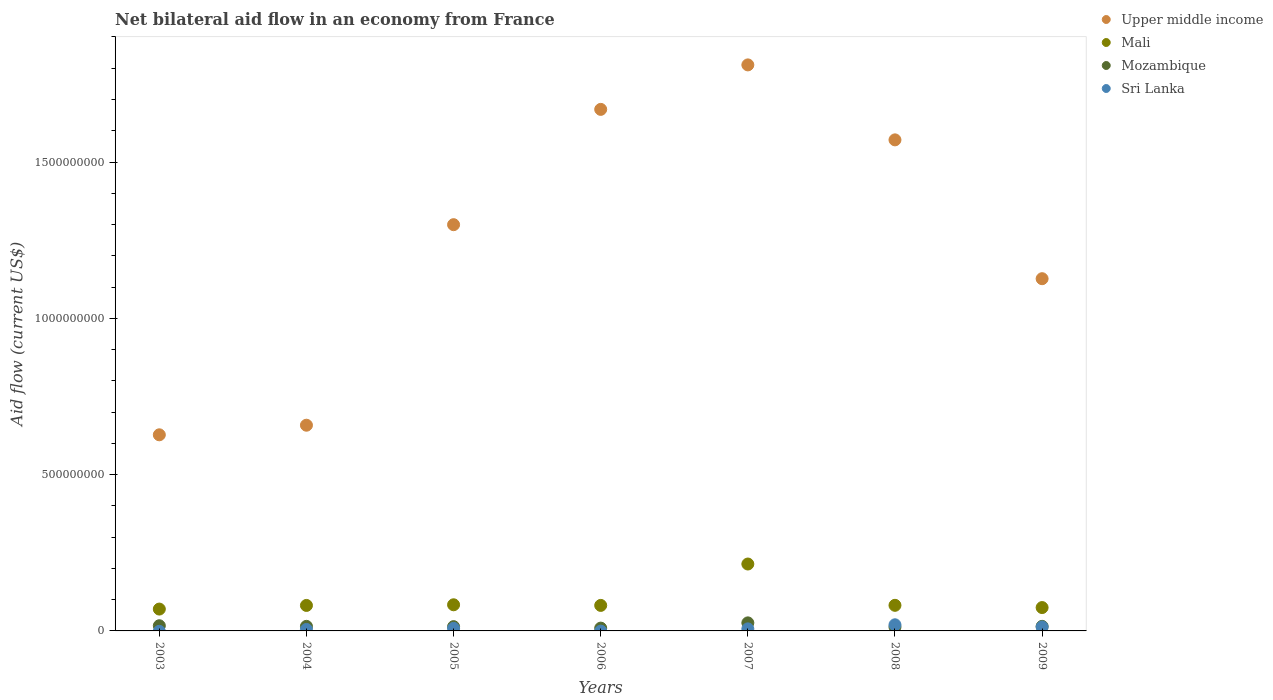Is the number of dotlines equal to the number of legend labels?
Your answer should be very brief. No. What is the net bilateral aid flow in Mozambique in 2004?
Keep it short and to the point. 1.46e+07. Across all years, what is the maximum net bilateral aid flow in Mali?
Make the answer very short. 2.14e+08. Across all years, what is the minimum net bilateral aid flow in Mozambique?
Make the answer very short. 8.98e+06. In which year was the net bilateral aid flow in Mozambique maximum?
Give a very brief answer. 2007. What is the total net bilateral aid flow in Mali in the graph?
Ensure brevity in your answer.  6.87e+08. What is the difference between the net bilateral aid flow in Upper middle income in 2007 and that in 2009?
Offer a terse response. 6.84e+08. What is the difference between the net bilateral aid flow in Mali in 2003 and the net bilateral aid flow in Upper middle income in 2009?
Offer a very short reply. -1.06e+09. What is the average net bilateral aid flow in Mali per year?
Keep it short and to the point. 9.82e+07. In the year 2005, what is the difference between the net bilateral aid flow in Mali and net bilateral aid flow in Sri Lanka?
Provide a short and direct response. 7.54e+07. In how many years, is the net bilateral aid flow in Mozambique greater than 1100000000 US$?
Your answer should be very brief. 0. What is the ratio of the net bilateral aid flow in Mozambique in 2004 to that in 2008?
Offer a very short reply. 1.19. What is the difference between the highest and the second highest net bilateral aid flow in Sri Lanka?
Make the answer very short. 6.92e+06. What is the difference between the highest and the lowest net bilateral aid flow in Sri Lanka?
Your answer should be very brief. 1.96e+07. In how many years, is the net bilateral aid flow in Upper middle income greater than the average net bilateral aid flow in Upper middle income taken over all years?
Make the answer very short. 4. Is the sum of the net bilateral aid flow in Mozambique in 2004 and 2007 greater than the maximum net bilateral aid flow in Upper middle income across all years?
Your answer should be very brief. No. Does the net bilateral aid flow in Mali monotonically increase over the years?
Offer a very short reply. No. Is the net bilateral aid flow in Sri Lanka strictly greater than the net bilateral aid flow in Mozambique over the years?
Ensure brevity in your answer.  No. Is the net bilateral aid flow in Upper middle income strictly less than the net bilateral aid flow in Mozambique over the years?
Your response must be concise. No. Does the graph contain any zero values?
Give a very brief answer. Yes. Where does the legend appear in the graph?
Give a very brief answer. Top right. How many legend labels are there?
Your answer should be very brief. 4. What is the title of the graph?
Provide a short and direct response. Net bilateral aid flow in an economy from France. What is the label or title of the X-axis?
Ensure brevity in your answer.  Years. What is the label or title of the Y-axis?
Provide a succinct answer. Aid flow (current US$). What is the Aid flow (current US$) of Upper middle income in 2003?
Offer a very short reply. 6.27e+08. What is the Aid flow (current US$) of Mali in 2003?
Your response must be concise. 6.99e+07. What is the Aid flow (current US$) of Mozambique in 2003?
Your answer should be compact. 1.66e+07. What is the Aid flow (current US$) of Upper middle income in 2004?
Provide a short and direct response. 6.58e+08. What is the Aid flow (current US$) of Mali in 2004?
Ensure brevity in your answer.  8.15e+07. What is the Aid flow (current US$) in Mozambique in 2004?
Offer a terse response. 1.46e+07. What is the Aid flow (current US$) of Sri Lanka in 2004?
Your response must be concise. 4.66e+06. What is the Aid flow (current US$) in Upper middle income in 2005?
Your answer should be very brief. 1.30e+09. What is the Aid flow (current US$) of Mali in 2005?
Give a very brief answer. 8.36e+07. What is the Aid flow (current US$) in Mozambique in 2005?
Provide a short and direct response. 1.37e+07. What is the Aid flow (current US$) of Sri Lanka in 2005?
Make the answer very short. 8.26e+06. What is the Aid flow (current US$) in Upper middle income in 2006?
Provide a short and direct response. 1.67e+09. What is the Aid flow (current US$) in Mali in 2006?
Offer a very short reply. 8.16e+07. What is the Aid flow (current US$) of Mozambique in 2006?
Your response must be concise. 8.98e+06. What is the Aid flow (current US$) of Sri Lanka in 2006?
Offer a very short reply. 0. What is the Aid flow (current US$) of Upper middle income in 2007?
Ensure brevity in your answer.  1.81e+09. What is the Aid flow (current US$) of Mali in 2007?
Offer a very short reply. 2.14e+08. What is the Aid flow (current US$) in Mozambique in 2007?
Provide a succinct answer. 2.57e+07. What is the Aid flow (current US$) of Sri Lanka in 2007?
Offer a very short reply. 6.54e+06. What is the Aid flow (current US$) in Upper middle income in 2008?
Your answer should be compact. 1.57e+09. What is the Aid flow (current US$) of Mali in 2008?
Ensure brevity in your answer.  8.19e+07. What is the Aid flow (current US$) in Mozambique in 2008?
Offer a terse response. 1.23e+07. What is the Aid flow (current US$) in Sri Lanka in 2008?
Offer a terse response. 1.96e+07. What is the Aid flow (current US$) of Upper middle income in 2009?
Your answer should be very brief. 1.13e+09. What is the Aid flow (current US$) in Mali in 2009?
Give a very brief answer. 7.47e+07. What is the Aid flow (current US$) of Mozambique in 2009?
Your response must be concise. 1.46e+07. What is the Aid flow (current US$) of Sri Lanka in 2009?
Provide a short and direct response. 1.27e+07. Across all years, what is the maximum Aid flow (current US$) in Upper middle income?
Provide a short and direct response. 1.81e+09. Across all years, what is the maximum Aid flow (current US$) of Mali?
Provide a succinct answer. 2.14e+08. Across all years, what is the maximum Aid flow (current US$) of Mozambique?
Give a very brief answer. 2.57e+07. Across all years, what is the maximum Aid flow (current US$) of Sri Lanka?
Your response must be concise. 1.96e+07. Across all years, what is the minimum Aid flow (current US$) of Upper middle income?
Offer a very short reply. 6.27e+08. Across all years, what is the minimum Aid flow (current US$) of Mali?
Ensure brevity in your answer.  6.99e+07. Across all years, what is the minimum Aid flow (current US$) in Mozambique?
Your answer should be compact. 8.98e+06. What is the total Aid flow (current US$) of Upper middle income in the graph?
Offer a very short reply. 8.76e+09. What is the total Aid flow (current US$) of Mali in the graph?
Your answer should be compact. 6.87e+08. What is the total Aid flow (current US$) of Mozambique in the graph?
Offer a terse response. 1.07e+08. What is the total Aid flow (current US$) in Sri Lanka in the graph?
Offer a terse response. 5.18e+07. What is the difference between the Aid flow (current US$) in Upper middle income in 2003 and that in 2004?
Make the answer very short. -3.07e+07. What is the difference between the Aid flow (current US$) of Mali in 2003 and that in 2004?
Ensure brevity in your answer.  -1.16e+07. What is the difference between the Aid flow (current US$) in Mozambique in 2003 and that in 2004?
Provide a succinct answer. 1.98e+06. What is the difference between the Aid flow (current US$) of Upper middle income in 2003 and that in 2005?
Your answer should be very brief. -6.72e+08. What is the difference between the Aid flow (current US$) of Mali in 2003 and that in 2005?
Your response must be concise. -1.37e+07. What is the difference between the Aid flow (current US$) in Mozambique in 2003 and that in 2005?
Provide a short and direct response. 2.91e+06. What is the difference between the Aid flow (current US$) of Upper middle income in 2003 and that in 2006?
Your answer should be very brief. -1.04e+09. What is the difference between the Aid flow (current US$) in Mali in 2003 and that in 2006?
Your response must be concise. -1.17e+07. What is the difference between the Aid flow (current US$) in Mozambique in 2003 and that in 2006?
Provide a succinct answer. 7.61e+06. What is the difference between the Aid flow (current US$) of Upper middle income in 2003 and that in 2007?
Provide a succinct answer. -1.18e+09. What is the difference between the Aid flow (current US$) in Mali in 2003 and that in 2007?
Your response must be concise. -1.44e+08. What is the difference between the Aid flow (current US$) of Mozambique in 2003 and that in 2007?
Offer a terse response. -9.15e+06. What is the difference between the Aid flow (current US$) in Upper middle income in 2003 and that in 2008?
Keep it short and to the point. -9.43e+08. What is the difference between the Aid flow (current US$) in Mali in 2003 and that in 2008?
Give a very brief answer. -1.20e+07. What is the difference between the Aid flow (current US$) in Mozambique in 2003 and that in 2008?
Offer a terse response. 4.28e+06. What is the difference between the Aid flow (current US$) of Upper middle income in 2003 and that in 2009?
Your answer should be very brief. -4.99e+08. What is the difference between the Aid flow (current US$) of Mali in 2003 and that in 2009?
Your response must be concise. -4.83e+06. What is the difference between the Aid flow (current US$) of Mozambique in 2003 and that in 2009?
Give a very brief answer. 1.94e+06. What is the difference between the Aid flow (current US$) in Upper middle income in 2004 and that in 2005?
Give a very brief answer. -6.41e+08. What is the difference between the Aid flow (current US$) of Mali in 2004 and that in 2005?
Make the answer very short. -2.09e+06. What is the difference between the Aid flow (current US$) in Mozambique in 2004 and that in 2005?
Give a very brief answer. 9.30e+05. What is the difference between the Aid flow (current US$) of Sri Lanka in 2004 and that in 2005?
Ensure brevity in your answer.  -3.60e+06. What is the difference between the Aid flow (current US$) of Upper middle income in 2004 and that in 2006?
Offer a very short reply. -1.01e+09. What is the difference between the Aid flow (current US$) in Mozambique in 2004 and that in 2006?
Ensure brevity in your answer.  5.63e+06. What is the difference between the Aid flow (current US$) of Upper middle income in 2004 and that in 2007?
Ensure brevity in your answer.  -1.15e+09. What is the difference between the Aid flow (current US$) in Mali in 2004 and that in 2007?
Offer a very short reply. -1.32e+08. What is the difference between the Aid flow (current US$) of Mozambique in 2004 and that in 2007?
Ensure brevity in your answer.  -1.11e+07. What is the difference between the Aid flow (current US$) of Sri Lanka in 2004 and that in 2007?
Offer a terse response. -1.88e+06. What is the difference between the Aid flow (current US$) of Upper middle income in 2004 and that in 2008?
Ensure brevity in your answer.  -9.13e+08. What is the difference between the Aid flow (current US$) of Mali in 2004 and that in 2008?
Provide a succinct answer. -3.80e+05. What is the difference between the Aid flow (current US$) of Mozambique in 2004 and that in 2008?
Your answer should be compact. 2.30e+06. What is the difference between the Aid flow (current US$) in Sri Lanka in 2004 and that in 2008?
Give a very brief answer. -1.50e+07. What is the difference between the Aid flow (current US$) in Upper middle income in 2004 and that in 2009?
Offer a terse response. -4.69e+08. What is the difference between the Aid flow (current US$) in Mali in 2004 and that in 2009?
Offer a very short reply. 6.80e+06. What is the difference between the Aid flow (current US$) of Mozambique in 2004 and that in 2009?
Provide a succinct answer. -4.00e+04. What is the difference between the Aid flow (current US$) of Sri Lanka in 2004 and that in 2009?
Provide a short and direct response. -8.03e+06. What is the difference between the Aid flow (current US$) of Upper middle income in 2005 and that in 2006?
Make the answer very short. -3.69e+08. What is the difference between the Aid flow (current US$) of Mali in 2005 and that in 2006?
Ensure brevity in your answer.  1.99e+06. What is the difference between the Aid flow (current US$) of Mozambique in 2005 and that in 2006?
Your answer should be compact. 4.70e+06. What is the difference between the Aid flow (current US$) in Upper middle income in 2005 and that in 2007?
Provide a succinct answer. -5.11e+08. What is the difference between the Aid flow (current US$) in Mali in 2005 and that in 2007?
Give a very brief answer. -1.30e+08. What is the difference between the Aid flow (current US$) in Mozambique in 2005 and that in 2007?
Provide a succinct answer. -1.21e+07. What is the difference between the Aid flow (current US$) of Sri Lanka in 2005 and that in 2007?
Offer a terse response. 1.72e+06. What is the difference between the Aid flow (current US$) in Upper middle income in 2005 and that in 2008?
Keep it short and to the point. -2.71e+08. What is the difference between the Aid flow (current US$) in Mali in 2005 and that in 2008?
Offer a very short reply. 1.71e+06. What is the difference between the Aid flow (current US$) of Mozambique in 2005 and that in 2008?
Your response must be concise. 1.37e+06. What is the difference between the Aid flow (current US$) of Sri Lanka in 2005 and that in 2008?
Your answer should be compact. -1.14e+07. What is the difference between the Aid flow (current US$) in Upper middle income in 2005 and that in 2009?
Your answer should be very brief. 1.73e+08. What is the difference between the Aid flow (current US$) in Mali in 2005 and that in 2009?
Give a very brief answer. 8.89e+06. What is the difference between the Aid flow (current US$) in Mozambique in 2005 and that in 2009?
Keep it short and to the point. -9.70e+05. What is the difference between the Aid flow (current US$) in Sri Lanka in 2005 and that in 2009?
Keep it short and to the point. -4.43e+06. What is the difference between the Aid flow (current US$) in Upper middle income in 2006 and that in 2007?
Your answer should be very brief. -1.42e+08. What is the difference between the Aid flow (current US$) of Mali in 2006 and that in 2007?
Your answer should be very brief. -1.32e+08. What is the difference between the Aid flow (current US$) in Mozambique in 2006 and that in 2007?
Your answer should be compact. -1.68e+07. What is the difference between the Aid flow (current US$) in Upper middle income in 2006 and that in 2008?
Your answer should be compact. 9.75e+07. What is the difference between the Aid flow (current US$) in Mali in 2006 and that in 2008?
Your answer should be compact. -2.80e+05. What is the difference between the Aid flow (current US$) in Mozambique in 2006 and that in 2008?
Offer a terse response. -3.33e+06. What is the difference between the Aid flow (current US$) in Upper middle income in 2006 and that in 2009?
Provide a short and direct response. 5.42e+08. What is the difference between the Aid flow (current US$) in Mali in 2006 and that in 2009?
Provide a short and direct response. 6.90e+06. What is the difference between the Aid flow (current US$) in Mozambique in 2006 and that in 2009?
Provide a short and direct response. -5.67e+06. What is the difference between the Aid flow (current US$) in Upper middle income in 2007 and that in 2008?
Offer a very short reply. 2.40e+08. What is the difference between the Aid flow (current US$) of Mali in 2007 and that in 2008?
Offer a very short reply. 1.32e+08. What is the difference between the Aid flow (current US$) in Mozambique in 2007 and that in 2008?
Offer a terse response. 1.34e+07. What is the difference between the Aid flow (current US$) in Sri Lanka in 2007 and that in 2008?
Offer a very short reply. -1.31e+07. What is the difference between the Aid flow (current US$) in Upper middle income in 2007 and that in 2009?
Ensure brevity in your answer.  6.84e+08. What is the difference between the Aid flow (current US$) in Mali in 2007 and that in 2009?
Ensure brevity in your answer.  1.39e+08. What is the difference between the Aid flow (current US$) in Mozambique in 2007 and that in 2009?
Provide a short and direct response. 1.11e+07. What is the difference between the Aid flow (current US$) in Sri Lanka in 2007 and that in 2009?
Provide a succinct answer. -6.15e+06. What is the difference between the Aid flow (current US$) of Upper middle income in 2008 and that in 2009?
Your answer should be compact. 4.44e+08. What is the difference between the Aid flow (current US$) in Mali in 2008 and that in 2009?
Your answer should be very brief. 7.18e+06. What is the difference between the Aid flow (current US$) in Mozambique in 2008 and that in 2009?
Provide a succinct answer. -2.34e+06. What is the difference between the Aid flow (current US$) of Sri Lanka in 2008 and that in 2009?
Your answer should be very brief. 6.92e+06. What is the difference between the Aid flow (current US$) of Upper middle income in 2003 and the Aid flow (current US$) of Mali in 2004?
Ensure brevity in your answer.  5.46e+08. What is the difference between the Aid flow (current US$) of Upper middle income in 2003 and the Aid flow (current US$) of Mozambique in 2004?
Provide a short and direct response. 6.13e+08. What is the difference between the Aid flow (current US$) of Upper middle income in 2003 and the Aid flow (current US$) of Sri Lanka in 2004?
Give a very brief answer. 6.23e+08. What is the difference between the Aid flow (current US$) in Mali in 2003 and the Aid flow (current US$) in Mozambique in 2004?
Offer a terse response. 5.53e+07. What is the difference between the Aid flow (current US$) in Mali in 2003 and the Aid flow (current US$) in Sri Lanka in 2004?
Ensure brevity in your answer.  6.52e+07. What is the difference between the Aid flow (current US$) of Mozambique in 2003 and the Aid flow (current US$) of Sri Lanka in 2004?
Offer a terse response. 1.19e+07. What is the difference between the Aid flow (current US$) of Upper middle income in 2003 and the Aid flow (current US$) of Mali in 2005?
Your answer should be very brief. 5.44e+08. What is the difference between the Aid flow (current US$) of Upper middle income in 2003 and the Aid flow (current US$) of Mozambique in 2005?
Keep it short and to the point. 6.14e+08. What is the difference between the Aid flow (current US$) of Upper middle income in 2003 and the Aid flow (current US$) of Sri Lanka in 2005?
Give a very brief answer. 6.19e+08. What is the difference between the Aid flow (current US$) in Mali in 2003 and the Aid flow (current US$) in Mozambique in 2005?
Your answer should be very brief. 5.62e+07. What is the difference between the Aid flow (current US$) in Mali in 2003 and the Aid flow (current US$) in Sri Lanka in 2005?
Ensure brevity in your answer.  6.16e+07. What is the difference between the Aid flow (current US$) of Mozambique in 2003 and the Aid flow (current US$) of Sri Lanka in 2005?
Ensure brevity in your answer.  8.33e+06. What is the difference between the Aid flow (current US$) in Upper middle income in 2003 and the Aid flow (current US$) in Mali in 2006?
Your answer should be very brief. 5.46e+08. What is the difference between the Aid flow (current US$) of Upper middle income in 2003 and the Aid flow (current US$) of Mozambique in 2006?
Give a very brief answer. 6.18e+08. What is the difference between the Aid flow (current US$) in Mali in 2003 and the Aid flow (current US$) in Mozambique in 2006?
Make the answer very short. 6.09e+07. What is the difference between the Aid flow (current US$) of Upper middle income in 2003 and the Aid flow (current US$) of Mali in 2007?
Provide a succinct answer. 4.13e+08. What is the difference between the Aid flow (current US$) in Upper middle income in 2003 and the Aid flow (current US$) in Mozambique in 2007?
Keep it short and to the point. 6.02e+08. What is the difference between the Aid flow (current US$) of Upper middle income in 2003 and the Aid flow (current US$) of Sri Lanka in 2007?
Your response must be concise. 6.21e+08. What is the difference between the Aid flow (current US$) in Mali in 2003 and the Aid flow (current US$) in Mozambique in 2007?
Ensure brevity in your answer.  4.42e+07. What is the difference between the Aid flow (current US$) in Mali in 2003 and the Aid flow (current US$) in Sri Lanka in 2007?
Keep it short and to the point. 6.34e+07. What is the difference between the Aid flow (current US$) in Mozambique in 2003 and the Aid flow (current US$) in Sri Lanka in 2007?
Your answer should be very brief. 1.00e+07. What is the difference between the Aid flow (current US$) of Upper middle income in 2003 and the Aid flow (current US$) of Mali in 2008?
Your answer should be compact. 5.45e+08. What is the difference between the Aid flow (current US$) in Upper middle income in 2003 and the Aid flow (current US$) in Mozambique in 2008?
Provide a succinct answer. 6.15e+08. What is the difference between the Aid flow (current US$) of Upper middle income in 2003 and the Aid flow (current US$) of Sri Lanka in 2008?
Give a very brief answer. 6.08e+08. What is the difference between the Aid flow (current US$) of Mali in 2003 and the Aid flow (current US$) of Mozambique in 2008?
Your answer should be very brief. 5.76e+07. What is the difference between the Aid flow (current US$) of Mali in 2003 and the Aid flow (current US$) of Sri Lanka in 2008?
Provide a succinct answer. 5.03e+07. What is the difference between the Aid flow (current US$) of Mozambique in 2003 and the Aid flow (current US$) of Sri Lanka in 2008?
Provide a succinct answer. -3.02e+06. What is the difference between the Aid flow (current US$) in Upper middle income in 2003 and the Aid flow (current US$) in Mali in 2009?
Your answer should be very brief. 5.53e+08. What is the difference between the Aid flow (current US$) in Upper middle income in 2003 and the Aid flow (current US$) in Mozambique in 2009?
Keep it short and to the point. 6.13e+08. What is the difference between the Aid flow (current US$) in Upper middle income in 2003 and the Aid flow (current US$) in Sri Lanka in 2009?
Keep it short and to the point. 6.15e+08. What is the difference between the Aid flow (current US$) of Mali in 2003 and the Aid flow (current US$) of Mozambique in 2009?
Offer a terse response. 5.52e+07. What is the difference between the Aid flow (current US$) of Mali in 2003 and the Aid flow (current US$) of Sri Lanka in 2009?
Provide a short and direct response. 5.72e+07. What is the difference between the Aid flow (current US$) in Mozambique in 2003 and the Aid flow (current US$) in Sri Lanka in 2009?
Your answer should be very brief. 3.90e+06. What is the difference between the Aid flow (current US$) in Upper middle income in 2004 and the Aid flow (current US$) in Mali in 2005?
Offer a very short reply. 5.74e+08. What is the difference between the Aid flow (current US$) of Upper middle income in 2004 and the Aid flow (current US$) of Mozambique in 2005?
Provide a short and direct response. 6.44e+08. What is the difference between the Aid flow (current US$) in Upper middle income in 2004 and the Aid flow (current US$) in Sri Lanka in 2005?
Your response must be concise. 6.50e+08. What is the difference between the Aid flow (current US$) of Mali in 2004 and the Aid flow (current US$) of Mozambique in 2005?
Your answer should be very brief. 6.78e+07. What is the difference between the Aid flow (current US$) of Mali in 2004 and the Aid flow (current US$) of Sri Lanka in 2005?
Provide a short and direct response. 7.33e+07. What is the difference between the Aid flow (current US$) in Mozambique in 2004 and the Aid flow (current US$) in Sri Lanka in 2005?
Provide a short and direct response. 6.35e+06. What is the difference between the Aid flow (current US$) in Upper middle income in 2004 and the Aid flow (current US$) in Mali in 2006?
Keep it short and to the point. 5.76e+08. What is the difference between the Aid flow (current US$) of Upper middle income in 2004 and the Aid flow (current US$) of Mozambique in 2006?
Keep it short and to the point. 6.49e+08. What is the difference between the Aid flow (current US$) in Mali in 2004 and the Aid flow (current US$) in Mozambique in 2006?
Keep it short and to the point. 7.25e+07. What is the difference between the Aid flow (current US$) of Upper middle income in 2004 and the Aid flow (current US$) of Mali in 2007?
Ensure brevity in your answer.  4.44e+08. What is the difference between the Aid flow (current US$) in Upper middle income in 2004 and the Aid flow (current US$) in Mozambique in 2007?
Offer a terse response. 6.32e+08. What is the difference between the Aid flow (current US$) in Upper middle income in 2004 and the Aid flow (current US$) in Sri Lanka in 2007?
Your answer should be compact. 6.51e+08. What is the difference between the Aid flow (current US$) in Mali in 2004 and the Aid flow (current US$) in Mozambique in 2007?
Give a very brief answer. 5.58e+07. What is the difference between the Aid flow (current US$) of Mali in 2004 and the Aid flow (current US$) of Sri Lanka in 2007?
Your answer should be very brief. 7.50e+07. What is the difference between the Aid flow (current US$) in Mozambique in 2004 and the Aid flow (current US$) in Sri Lanka in 2007?
Your response must be concise. 8.07e+06. What is the difference between the Aid flow (current US$) in Upper middle income in 2004 and the Aid flow (current US$) in Mali in 2008?
Make the answer very short. 5.76e+08. What is the difference between the Aid flow (current US$) in Upper middle income in 2004 and the Aid flow (current US$) in Mozambique in 2008?
Your answer should be compact. 6.46e+08. What is the difference between the Aid flow (current US$) in Upper middle income in 2004 and the Aid flow (current US$) in Sri Lanka in 2008?
Provide a succinct answer. 6.38e+08. What is the difference between the Aid flow (current US$) in Mali in 2004 and the Aid flow (current US$) in Mozambique in 2008?
Your answer should be compact. 6.92e+07. What is the difference between the Aid flow (current US$) of Mali in 2004 and the Aid flow (current US$) of Sri Lanka in 2008?
Offer a very short reply. 6.19e+07. What is the difference between the Aid flow (current US$) of Mozambique in 2004 and the Aid flow (current US$) of Sri Lanka in 2008?
Offer a very short reply. -5.00e+06. What is the difference between the Aid flow (current US$) in Upper middle income in 2004 and the Aid flow (current US$) in Mali in 2009?
Ensure brevity in your answer.  5.83e+08. What is the difference between the Aid flow (current US$) in Upper middle income in 2004 and the Aid flow (current US$) in Mozambique in 2009?
Offer a terse response. 6.43e+08. What is the difference between the Aid flow (current US$) in Upper middle income in 2004 and the Aid flow (current US$) in Sri Lanka in 2009?
Keep it short and to the point. 6.45e+08. What is the difference between the Aid flow (current US$) of Mali in 2004 and the Aid flow (current US$) of Mozambique in 2009?
Keep it short and to the point. 6.69e+07. What is the difference between the Aid flow (current US$) in Mali in 2004 and the Aid flow (current US$) in Sri Lanka in 2009?
Offer a very short reply. 6.88e+07. What is the difference between the Aid flow (current US$) of Mozambique in 2004 and the Aid flow (current US$) of Sri Lanka in 2009?
Provide a succinct answer. 1.92e+06. What is the difference between the Aid flow (current US$) in Upper middle income in 2005 and the Aid flow (current US$) in Mali in 2006?
Offer a terse response. 1.22e+09. What is the difference between the Aid flow (current US$) of Upper middle income in 2005 and the Aid flow (current US$) of Mozambique in 2006?
Provide a short and direct response. 1.29e+09. What is the difference between the Aid flow (current US$) in Mali in 2005 and the Aid flow (current US$) in Mozambique in 2006?
Offer a terse response. 7.46e+07. What is the difference between the Aid flow (current US$) in Upper middle income in 2005 and the Aid flow (current US$) in Mali in 2007?
Offer a very short reply. 1.09e+09. What is the difference between the Aid flow (current US$) of Upper middle income in 2005 and the Aid flow (current US$) of Mozambique in 2007?
Make the answer very short. 1.27e+09. What is the difference between the Aid flow (current US$) in Upper middle income in 2005 and the Aid flow (current US$) in Sri Lanka in 2007?
Provide a succinct answer. 1.29e+09. What is the difference between the Aid flow (current US$) in Mali in 2005 and the Aid flow (current US$) in Mozambique in 2007?
Your answer should be very brief. 5.79e+07. What is the difference between the Aid flow (current US$) of Mali in 2005 and the Aid flow (current US$) of Sri Lanka in 2007?
Give a very brief answer. 7.71e+07. What is the difference between the Aid flow (current US$) of Mozambique in 2005 and the Aid flow (current US$) of Sri Lanka in 2007?
Provide a succinct answer. 7.14e+06. What is the difference between the Aid flow (current US$) of Upper middle income in 2005 and the Aid flow (current US$) of Mali in 2008?
Keep it short and to the point. 1.22e+09. What is the difference between the Aid flow (current US$) of Upper middle income in 2005 and the Aid flow (current US$) of Mozambique in 2008?
Provide a succinct answer. 1.29e+09. What is the difference between the Aid flow (current US$) in Upper middle income in 2005 and the Aid flow (current US$) in Sri Lanka in 2008?
Provide a succinct answer. 1.28e+09. What is the difference between the Aid flow (current US$) in Mali in 2005 and the Aid flow (current US$) in Mozambique in 2008?
Your answer should be very brief. 7.13e+07. What is the difference between the Aid flow (current US$) in Mali in 2005 and the Aid flow (current US$) in Sri Lanka in 2008?
Your answer should be compact. 6.40e+07. What is the difference between the Aid flow (current US$) of Mozambique in 2005 and the Aid flow (current US$) of Sri Lanka in 2008?
Make the answer very short. -5.93e+06. What is the difference between the Aid flow (current US$) of Upper middle income in 2005 and the Aid flow (current US$) of Mali in 2009?
Keep it short and to the point. 1.22e+09. What is the difference between the Aid flow (current US$) in Upper middle income in 2005 and the Aid flow (current US$) in Mozambique in 2009?
Your answer should be compact. 1.28e+09. What is the difference between the Aid flow (current US$) of Upper middle income in 2005 and the Aid flow (current US$) of Sri Lanka in 2009?
Keep it short and to the point. 1.29e+09. What is the difference between the Aid flow (current US$) of Mali in 2005 and the Aid flow (current US$) of Mozambique in 2009?
Ensure brevity in your answer.  6.90e+07. What is the difference between the Aid flow (current US$) of Mali in 2005 and the Aid flow (current US$) of Sri Lanka in 2009?
Your answer should be compact. 7.09e+07. What is the difference between the Aid flow (current US$) of Mozambique in 2005 and the Aid flow (current US$) of Sri Lanka in 2009?
Keep it short and to the point. 9.90e+05. What is the difference between the Aid flow (current US$) of Upper middle income in 2006 and the Aid flow (current US$) of Mali in 2007?
Your answer should be very brief. 1.45e+09. What is the difference between the Aid flow (current US$) of Upper middle income in 2006 and the Aid flow (current US$) of Mozambique in 2007?
Offer a terse response. 1.64e+09. What is the difference between the Aid flow (current US$) in Upper middle income in 2006 and the Aid flow (current US$) in Sri Lanka in 2007?
Your answer should be compact. 1.66e+09. What is the difference between the Aid flow (current US$) of Mali in 2006 and the Aid flow (current US$) of Mozambique in 2007?
Make the answer very short. 5.59e+07. What is the difference between the Aid flow (current US$) of Mali in 2006 and the Aid flow (current US$) of Sri Lanka in 2007?
Provide a succinct answer. 7.51e+07. What is the difference between the Aid flow (current US$) of Mozambique in 2006 and the Aid flow (current US$) of Sri Lanka in 2007?
Your response must be concise. 2.44e+06. What is the difference between the Aid flow (current US$) of Upper middle income in 2006 and the Aid flow (current US$) of Mali in 2008?
Ensure brevity in your answer.  1.59e+09. What is the difference between the Aid flow (current US$) of Upper middle income in 2006 and the Aid flow (current US$) of Mozambique in 2008?
Your answer should be compact. 1.66e+09. What is the difference between the Aid flow (current US$) of Upper middle income in 2006 and the Aid flow (current US$) of Sri Lanka in 2008?
Provide a short and direct response. 1.65e+09. What is the difference between the Aid flow (current US$) of Mali in 2006 and the Aid flow (current US$) of Mozambique in 2008?
Offer a very short reply. 6.93e+07. What is the difference between the Aid flow (current US$) in Mali in 2006 and the Aid flow (current US$) in Sri Lanka in 2008?
Make the answer very short. 6.20e+07. What is the difference between the Aid flow (current US$) in Mozambique in 2006 and the Aid flow (current US$) in Sri Lanka in 2008?
Your answer should be compact. -1.06e+07. What is the difference between the Aid flow (current US$) in Upper middle income in 2006 and the Aid flow (current US$) in Mali in 2009?
Ensure brevity in your answer.  1.59e+09. What is the difference between the Aid flow (current US$) of Upper middle income in 2006 and the Aid flow (current US$) of Mozambique in 2009?
Your response must be concise. 1.65e+09. What is the difference between the Aid flow (current US$) of Upper middle income in 2006 and the Aid flow (current US$) of Sri Lanka in 2009?
Provide a short and direct response. 1.66e+09. What is the difference between the Aid flow (current US$) in Mali in 2006 and the Aid flow (current US$) in Mozambique in 2009?
Provide a short and direct response. 6.70e+07. What is the difference between the Aid flow (current US$) of Mali in 2006 and the Aid flow (current US$) of Sri Lanka in 2009?
Keep it short and to the point. 6.89e+07. What is the difference between the Aid flow (current US$) of Mozambique in 2006 and the Aid flow (current US$) of Sri Lanka in 2009?
Your answer should be very brief. -3.71e+06. What is the difference between the Aid flow (current US$) of Upper middle income in 2007 and the Aid flow (current US$) of Mali in 2008?
Your answer should be compact. 1.73e+09. What is the difference between the Aid flow (current US$) of Upper middle income in 2007 and the Aid flow (current US$) of Mozambique in 2008?
Your response must be concise. 1.80e+09. What is the difference between the Aid flow (current US$) of Upper middle income in 2007 and the Aid flow (current US$) of Sri Lanka in 2008?
Ensure brevity in your answer.  1.79e+09. What is the difference between the Aid flow (current US$) of Mali in 2007 and the Aid flow (current US$) of Mozambique in 2008?
Give a very brief answer. 2.02e+08. What is the difference between the Aid flow (current US$) of Mali in 2007 and the Aid flow (current US$) of Sri Lanka in 2008?
Provide a short and direct response. 1.94e+08. What is the difference between the Aid flow (current US$) of Mozambique in 2007 and the Aid flow (current US$) of Sri Lanka in 2008?
Offer a terse response. 6.13e+06. What is the difference between the Aid flow (current US$) in Upper middle income in 2007 and the Aid flow (current US$) in Mali in 2009?
Ensure brevity in your answer.  1.74e+09. What is the difference between the Aid flow (current US$) in Upper middle income in 2007 and the Aid flow (current US$) in Mozambique in 2009?
Your response must be concise. 1.80e+09. What is the difference between the Aid flow (current US$) in Upper middle income in 2007 and the Aid flow (current US$) in Sri Lanka in 2009?
Provide a short and direct response. 1.80e+09. What is the difference between the Aid flow (current US$) in Mali in 2007 and the Aid flow (current US$) in Mozambique in 2009?
Your answer should be very brief. 1.99e+08. What is the difference between the Aid flow (current US$) of Mali in 2007 and the Aid flow (current US$) of Sri Lanka in 2009?
Ensure brevity in your answer.  2.01e+08. What is the difference between the Aid flow (current US$) of Mozambique in 2007 and the Aid flow (current US$) of Sri Lanka in 2009?
Provide a succinct answer. 1.30e+07. What is the difference between the Aid flow (current US$) in Upper middle income in 2008 and the Aid flow (current US$) in Mali in 2009?
Provide a short and direct response. 1.50e+09. What is the difference between the Aid flow (current US$) of Upper middle income in 2008 and the Aid flow (current US$) of Mozambique in 2009?
Your answer should be compact. 1.56e+09. What is the difference between the Aid flow (current US$) of Upper middle income in 2008 and the Aid flow (current US$) of Sri Lanka in 2009?
Give a very brief answer. 1.56e+09. What is the difference between the Aid flow (current US$) of Mali in 2008 and the Aid flow (current US$) of Mozambique in 2009?
Provide a succinct answer. 6.72e+07. What is the difference between the Aid flow (current US$) of Mali in 2008 and the Aid flow (current US$) of Sri Lanka in 2009?
Ensure brevity in your answer.  6.92e+07. What is the difference between the Aid flow (current US$) of Mozambique in 2008 and the Aid flow (current US$) of Sri Lanka in 2009?
Keep it short and to the point. -3.80e+05. What is the average Aid flow (current US$) in Upper middle income per year?
Make the answer very short. 1.25e+09. What is the average Aid flow (current US$) of Mali per year?
Provide a succinct answer. 9.82e+07. What is the average Aid flow (current US$) in Mozambique per year?
Offer a very short reply. 1.52e+07. What is the average Aid flow (current US$) of Sri Lanka per year?
Ensure brevity in your answer.  7.39e+06. In the year 2003, what is the difference between the Aid flow (current US$) of Upper middle income and Aid flow (current US$) of Mali?
Provide a succinct answer. 5.57e+08. In the year 2003, what is the difference between the Aid flow (current US$) of Upper middle income and Aid flow (current US$) of Mozambique?
Keep it short and to the point. 6.11e+08. In the year 2003, what is the difference between the Aid flow (current US$) of Mali and Aid flow (current US$) of Mozambique?
Your answer should be very brief. 5.33e+07. In the year 2004, what is the difference between the Aid flow (current US$) of Upper middle income and Aid flow (current US$) of Mali?
Your response must be concise. 5.76e+08. In the year 2004, what is the difference between the Aid flow (current US$) of Upper middle income and Aid flow (current US$) of Mozambique?
Give a very brief answer. 6.43e+08. In the year 2004, what is the difference between the Aid flow (current US$) of Upper middle income and Aid flow (current US$) of Sri Lanka?
Your response must be concise. 6.53e+08. In the year 2004, what is the difference between the Aid flow (current US$) in Mali and Aid flow (current US$) in Mozambique?
Give a very brief answer. 6.69e+07. In the year 2004, what is the difference between the Aid flow (current US$) in Mali and Aid flow (current US$) in Sri Lanka?
Provide a short and direct response. 7.69e+07. In the year 2004, what is the difference between the Aid flow (current US$) in Mozambique and Aid flow (current US$) in Sri Lanka?
Keep it short and to the point. 9.95e+06. In the year 2005, what is the difference between the Aid flow (current US$) of Upper middle income and Aid flow (current US$) of Mali?
Provide a short and direct response. 1.22e+09. In the year 2005, what is the difference between the Aid flow (current US$) of Upper middle income and Aid flow (current US$) of Mozambique?
Provide a short and direct response. 1.29e+09. In the year 2005, what is the difference between the Aid flow (current US$) of Upper middle income and Aid flow (current US$) of Sri Lanka?
Offer a very short reply. 1.29e+09. In the year 2005, what is the difference between the Aid flow (current US$) of Mali and Aid flow (current US$) of Mozambique?
Provide a succinct answer. 6.99e+07. In the year 2005, what is the difference between the Aid flow (current US$) of Mali and Aid flow (current US$) of Sri Lanka?
Provide a succinct answer. 7.54e+07. In the year 2005, what is the difference between the Aid flow (current US$) in Mozambique and Aid flow (current US$) in Sri Lanka?
Make the answer very short. 5.42e+06. In the year 2006, what is the difference between the Aid flow (current US$) in Upper middle income and Aid flow (current US$) in Mali?
Make the answer very short. 1.59e+09. In the year 2006, what is the difference between the Aid flow (current US$) of Upper middle income and Aid flow (current US$) of Mozambique?
Provide a short and direct response. 1.66e+09. In the year 2006, what is the difference between the Aid flow (current US$) in Mali and Aid flow (current US$) in Mozambique?
Make the answer very short. 7.26e+07. In the year 2007, what is the difference between the Aid flow (current US$) of Upper middle income and Aid flow (current US$) of Mali?
Your answer should be very brief. 1.60e+09. In the year 2007, what is the difference between the Aid flow (current US$) in Upper middle income and Aid flow (current US$) in Mozambique?
Offer a terse response. 1.78e+09. In the year 2007, what is the difference between the Aid flow (current US$) of Upper middle income and Aid flow (current US$) of Sri Lanka?
Ensure brevity in your answer.  1.80e+09. In the year 2007, what is the difference between the Aid flow (current US$) of Mali and Aid flow (current US$) of Mozambique?
Keep it short and to the point. 1.88e+08. In the year 2007, what is the difference between the Aid flow (current US$) of Mali and Aid flow (current US$) of Sri Lanka?
Provide a succinct answer. 2.07e+08. In the year 2007, what is the difference between the Aid flow (current US$) of Mozambique and Aid flow (current US$) of Sri Lanka?
Offer a very short reply. 1.92e+07. In the year 2008, what is the difference between the Aid flow (current US$) in Upper middle income and Aid flow (current US$) in Mali?
Keep it short and to the point. 1.49e+09. In the year 2008, what is the difference between the Aid flow (current US$) of Upper middle income and Aid flow (current US$) of Mozambique?
Provide a short and direct response. 1.56e+09. In the year 2008, what is the difference between the Aid flow (current US$) of Upper middle income and Aid flow (current US$) of Sri Lanka?
Provide a succinct answer. 1.55e+09. In the year 2008, what is the difference between the Aid flow (current US$) of Mali and Aid flow (current US$) of Mozambique?
Ensure brevity in your answer.  6.96e+07. In the year 2008, what is the difference between the Aid flow (current US$) in Mali and Aid flow (current US$) in Sri Lanka?
Give a very brief answer. 6.23e+07. In the year 2008, what is the difference between the Aid flow (current US$) in Mozambique and Aid flow (current US$) in Sri Lanka?
Provide a succinct answer. -7.30e+06. In the year 2009, what is the difference between the Aid flow (current US$) in Upper middle income and Aid flow (current US$) in Mali?
Your response must be concise. 1.05e+09. In the year 2009, what is the difference between the Aid flow (current US$) in Upper middle income and Aid flow (current US$) in Mozambique?
Provide a succinct answer. 1.11e+09. In the year 2009, what is the difference between the Aid flow (current US$) of Upper middle income and Aid flow (current US$) of Sri Lanka?
Offer a terse response. 1.11e+09. In the year 2009, what is the difference between the Aid flow (current US$) in Mali and Aid flow (current US$) in Mozambique?
Your answer should be very brief. 6.01e+07. In the year 2009, what is the difference between the Aid flow (current US$) of Mali and Aid flow (current US$) of Sri Lanka?
Your answer should be very brief. 6.20e+07. In the year 2009, what is the difference between the Aid flow (current US$) of Mozambique and Aid flow (current US$) of Sri Lanka?
Make the answer very short. 1.96e+06. What is the ratio of the Aid flow (current US$) of Upper middle income in 2003 to that in 2004?
Make the answer very short. 0.95. What is the ratio of the Aid flow (current US$) of Mali in 2003 to that in 2004?
Your answer should be very brief. 0.86. What is the ratio of the Aid flow (current US$) of Mozambique in 2003 to that in 2004?
Offer a terse response. 1.14. What is the ratio of the Aid flow (current US$) of Upper middle income in 2003 to that in 2005?
Keep it short and to the point. 0.48. What is the ratio of the Aid flow (current US$) of Mali in 2003 to that in 2005?
Make the answer very short. 0.84. What is the ratio of the Aid flow (current US$) of Mozambique in 2003 to that in 2005?
Offer a very short reply. 1.21. What is the ratio of the Aid flow (current US$) in Upper middle income in 2003 to that in 2006?
Give a very brief answer. 0.38. What is the ratio of the Aid flow (current US$) in Mali in 2003 to that in 2006?
Make the answer very short. 0.86. What is the ratio of the Aid flow (current US$) in Mozambique in 2003 to that in 2006?
Your answer should be compact. 1.85. What is the ratio of the Aid flow (current US$) of Upper middle income in 2003 to that in 2007?
Your answer should be very brief. 0.35. What is the ratio of the Aid flow (current US$) in Mali in 2003 to that in 2007?
Provide a succinct answer. 0.33. What is the ratio of the Aid flow (current US$) in Mozambique in 2003 to that in 2007?
Ensure brevity in your answer.  0.64. What is the ratio of the Aid flow (current US$) in Upper middle income in 2003 to that in 2008?
Provide a short and direct response. 0.4. What is the ratio of the Aid flow (current US$) of Mali in 2003 to that in 2008?
Offer a terse response. 0.85. What is the ratio of the Aid flow (current US$) in Mozambique in 2003 to that in 2008?
Make the answer very short. 1.35. What is the ratio of the Aid flow (current US$) of Upper middle income in 2003 to that in 2009?
Ensure brevity in your answer.  0.56. What is the ratio of the Aid flow (current US$) in Mali in 2003 to that in 2009?
Offer a terse response. 0.94. What is the ratio of the Aid flow (current US$) of Mozambique in 2003 to that in 2009?
Keep it short and to the point. 1.13. What is the ratio of the Aid flow (current US$) of Upper middle income in 2004 to that in 2005?
Offer a very short reply. 0.51. What is the ratio of the Aid flow (current US$) in Mozambique in 2004 to that in 2005?
Ensure brevity in your answer.  1.07. What is the ratio of the Aid flow (current US$) in Sri Lanka in 2004 to that in 2005?
Make the answer very short. 0.56. What is the ratio of the Aid flow (current US$) in Upper middle income in 2004 to that in 2006?
Ensure brevity in your answer.  0.39. What is the ratio of the Aid flow (current US$) in Mozambique in 2004 to that in 2006?
Ensure brevity in your answer.  1.63. What is the ratio of the Aid flow (current US$) of Upper middle income in 2004 to that in 2007?
Offer a very short reply. 0.36. What is the ratio of the Aid flow (current US$) in Mali in 2004 to that in 2007?
Offer a terse response. 0.38. What is the ratio of the Aid flow (current US$) of Mozambique in 2004 to that in 2007?
Your response must be concise. 0.57. What is the ratio of the Aid flow (current US$) of Sri Lanka in 2004 to that in 2007?
Ensure brevity in your answer.  0.71. What is the ratio of the Aid flow (current US$) in Upper middle income in 2004 to that in 2008?
Provide a succinct answer. 0.42. What is the ratio of the Aid flow (current US$) in Mali in 2004 to that in 2008?
Your answer should be compact. 1. What is the ratio of the Aid flow (current US$) of Mozambique in 2004 to that in 2008?
Provide a short and direct response. 1.19. What is the ratio of the Aid flow (current US$) of Sri Lanka in 2004 to that in 2008?
Offer a very short reply. 0.24. What is the ratio of the Aid flow (current US$) of Upper middle income in 2004 to that in 2009?
Offer a terse response. 0.58. What is the ratio of the Aid flow (current US$) in Mali in 2004 to that in 2009?
Your answer should be very brief. 1.09. What is the ratio of the Aid flow (current US$) of Mozambique in 2004 to that in 2009?
Your answer should be compact. 1. What is the ratio of the Aid flow (current US$) of Sri Lanka in 2004 to that in 2009?
Make the answer very short. 0.37. What is the ratio of the Aid flow (current US$) of Upper middle income in 2005 to that in 2006?
Offer a terse response. 0.78. What is the ratio of the Aid flow (current US$) in Mali in 2005 to that in 2006?
Make the answer very short. 1.02. What is the ratio of the Aid flow (current US$) of Mozambique in 2005 to that in 2006?
Your answer should be very brief. 1.52. What is the ratio of the Aid flow (current US$) in Upper middle income in 2005 to that in 2007?
Make the answer very short. 0.72. What is the ratio of the Aid flow (current US$) in Mali in 2005 to that in 2007?
Provide a succinct answer. 0.39. What is the ratio of the Aid flow (current US$) in Mozambique in 2005 to that in 2007?
Provide a short and direct response. 0.53. What is the ratio of the Aid flow (current US$) in Sri Lanka in 2005 to that in 2007?
Provide a short and direct response. 1.26. What is the ratio of the Aid flow (current US$) in Upper middle income in 2005 to that in 2008?
Keep it short and to the point. 0.83. What is the ratio of the Aid flow (current US$) of Mali in 2005 to that in 2008?
Offer a very short reply. 1.02. What is the ratio of the Aid flow (current US$) in Mozambique in 2005 to that in 2008?
Offer a very short reply. 1.11. What is the ratio of the Aid flow (current US$) of Sri Lanka in 2005 to that in 2008?
Ensure brevity in your answer.  0.42. What is the ratio of the Aid flow (current US$) of Upper middle income in 2005 to that in 2009?
Your response must be concise. 1.15. What is the ratio of the Aid flow (current US$) in Mali in 2005 to that in 2009?
Give a very brief answer. 1.12. What is the ratio of the Aid flow (current US$) of Mozambique in 2005 to that in 2009?
Your answer should be compact. 0.93. What is the ratio of the Aid flow (current US$) in Sri Lanka in 2005 to that in 2009?
Make the answer very short. 0.65. What is the ratio of the Aid flow (current US$) in Upper middle income in 2006 to that in 2007?
Your answer should be compact. 0.92. What is the ratio of the Aid flow (current US$) in Mali in 2006 to that in 2007?
Keep it short and to the point. 0.38. What is the ratio of the Aid flow (current US$) in Mozambique in 2006 to that in 2007?
Provide a short and direct response. 0.35. What is the ratio of the Aid flow (current US$) in Upper middle income in 2006 to that in 2008?
Offer a very short reply. 1.06. What is the ratio of the Aid flow (current US$) of Mali in 2006 to that in 2008?
Provide a short and direct response. 1. What is the ratio of the Aid flow (current US$) of Mozambique in 2006 to that in 2008?
Make the answer very short. 0.73. What is the ratio of the Aid flow (current US$) in Upper middle income in 2006 to that in 2009?
Provide a short and direct response. 1.48. What is the ratio of the Aid flow (current US$) in Mali in 2006 to that in 2009?
Offer a terse response. 1.09. What is the ratio of the Aid flow (current US$) of Mozambique in 2006 to that in 2009?
Keep it short and to the point. 0.61. What is the ratio of the Aid flow (current US$) in Upper middle income in 2007 to that in 2008?
Ensure brevity in your answer.  1.15. What is the ratio of the Aid flow (current US$) in Mali in 2007 to that in 2008?
Your answer should be very brief. 2.61. What is the ratio of the Aid flow (current US$) in Mozambique in 2007 to that in 2008?
Provide a succinct answer. 2.09. What is the ratio of the Aid flow (current US$) in Sri Lanka in 2007 to that in 2008?
Keep it short and to the point. 0.33. What is the ratio of the Aid flow (current US$) in Upper middle income in 2007 to that in 2009?
Provide a short and direct response. 1.61. What is the ratio of the Aid flow (current US$) of Mali in 2007 to that in 2009?
Provide a succinct answer. 2.86. What is the ratio of the Aid flow (current US$) of Mozambique in 2007 to that in 2009?
Provide a succinct answer. 1.76. What is the ratio of the Aid flow (current US$) of Sri Lanka in 2007 to that in 2009?
Your answer should be compact. 0.52. What is the ratio of the Aid flow (current US$) in Upper middle income in 2008 to that in 2009?
Give a very brief answer. 1.39. What is the ratio of the Aid flow (current US$) of Mali in 2008 to that in 2009?
Provide a succinct answer. 1.1. What is the ratio of the Aid flow (current US$) of Mozambique in 2008 to that in 2009?
Offer a terse response. 0.84. What is the ratio of the Aid flow (current US$) of Sri Lanka in 2008 to that in 2009?
Offer a terse response. 1.55. What is the difference between the highest and the second highest Aid flow (current US$) of Upper middle income?
Make the answer very short. 1.42e+08. What is the difference between the highest and the second highest Aid flow (current US$) of Mali?
Your answer should be compact. 1.30e+08. What is the difference between the highest and the second highest Aid flow (current US$) of Mozambique?
Provide a short and direct response. 9.15e+06. What is the difference between the highest and the second highest Aid flow (current US$) in Sri Lanka?
Your response must be concise. 6.92e+06. What is the difference between the highest and the lowest Aid flow (current US$) in Upper middle income?
Your answer should be compact. 1.18e+09. What is the difference between the highest and the lowest Aid flow (current US$) in Mali?
Your answer should be compact. 1.44e+08. What is the difference between the highest and the lowest Aid flow (current US$) in Mozambique?
Offer a very short reply. 1.68e+07. What is the difference between the highest and the lowest Aid flow (current US$) of Sri Lanka?
Make the answer very short. 1.96e+07. 